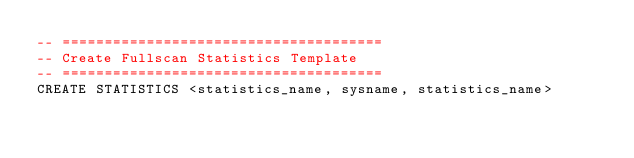Convert code to text. <code><loc_0><loc_0><loc_500><loc_500><_SQL_>-- ======================================
-- Create Fullscan Statistics Template
-- ======================================
CREATE STATISTICS <statistics_name, sysname, statistics_name> </code> 